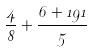<formula> <loc_0><loc_0><loc_500><loc_500>\frac { 4 } { 8 } + \frac { 6 + 1 9 1 } { 5 }</formula> 